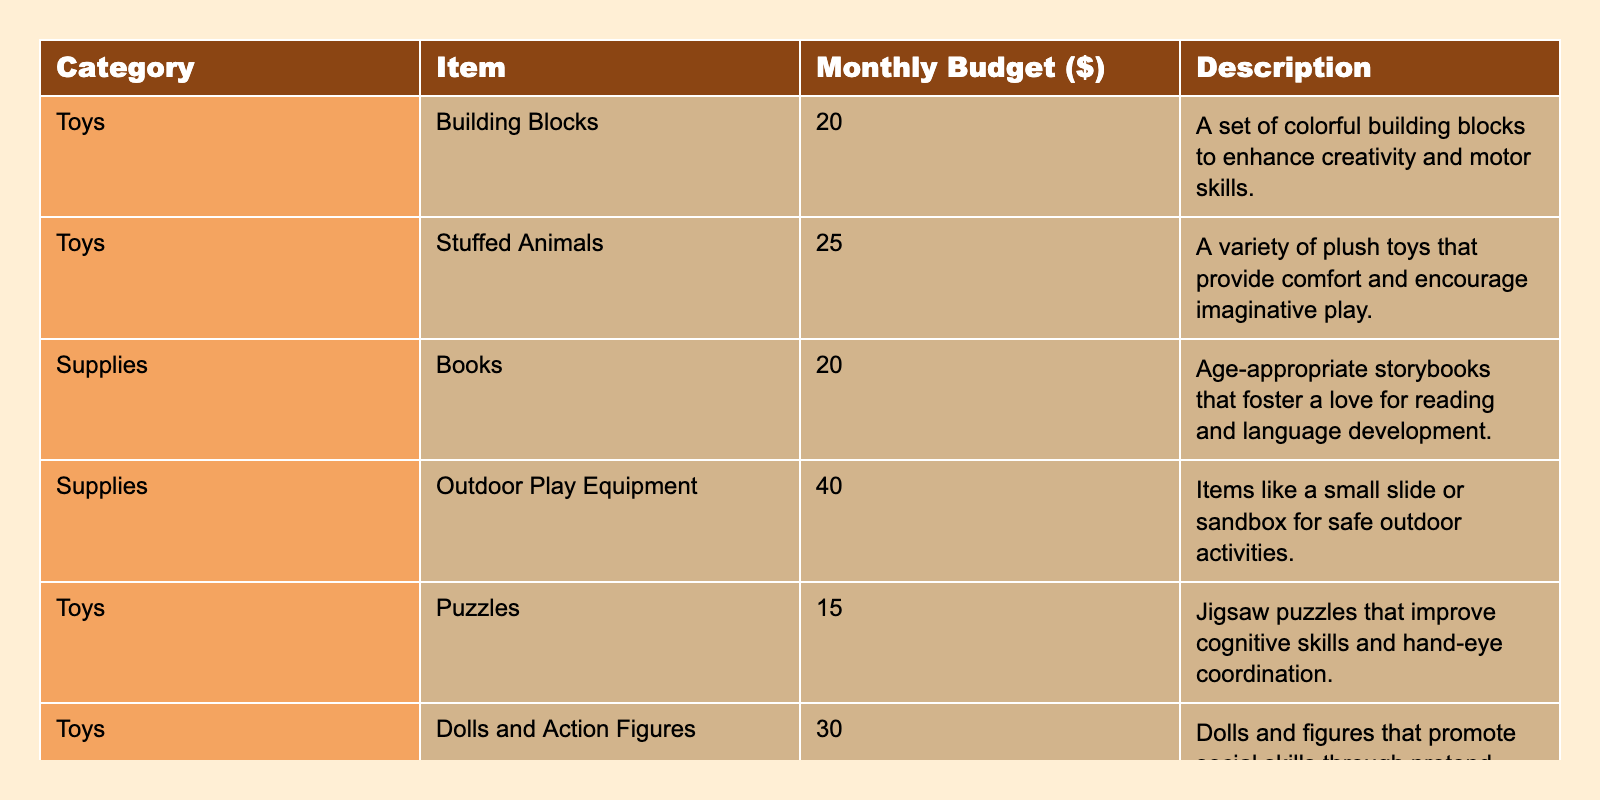What is the total monthly budget allocated for books? The table lists books under the supplies category with a budget of $20. Therefore, the total monthly allocation for books is simply this amount.
Answer: 20 How much more is allocated for outdoor play equipment compared to puzzles? The budget for outdoor play equipment is $40, and the budget for puzzles is $15. To find the difference, subtract 15 from 40, which equals 25.
Answer: 25 What is the total budget for toys? The monthly budgets for toys are: Building Blocks ($20), Stuffed Animals ($25), Puzzles ($15), Dolls and Action Figures ($30), and Musical Instruments ($25). Adding these amounts gives a total of 20 + 25 + 15 + 30 + 25 = 115.
Answer: 115 Are there more toys or supplies in the budget? The table shows 5 items under toys (Building Blocks, Stuffed Animals, Puzzles, Dolls and Action Figures, Musical Instruments) and 2 items under supplies (Books, Outdoor Play Equipment). Since 5 is greater than 2, the answer is yes.
Answer: Yes What is the average budget for toys? The budgets for toys are: $20, $25, $15, $30, $25. To calculate the average, first sum these values (20 + 25 + 15 + 30 + 25 = 115) and divide by the number of items (5). So, 115 divided by 5 equals 23.
Answer: 23 If you combine the budgets for supplies, what is the total? The total monthly budgets for supplies are: Books ($20) and Outdoor Play Equipment ($40). Adding these amounts, we get 20 + 40 = 60.
Answer: 60 Which item has the highest budget allocation? Looking through the items, Outdoor Play Equipment has a budget of $40, which is higher than all other items in the table. Therefore, it has the highest allocation.
Answer: Outdoor Play Equipment What is the combined budget for stuffed animals and musical instruments? The budget for stuffed animals is $25 and for musical instruments is $25 as well. Combining these budgets, we calculate 25 + 25 = 50.
Answer: 50 Is the budget for dolls and action figures equal to the budget for building blocks? The budget for dolls and action figures is $30, while building blocks is $20. Since 30 does not equal 20, the answer is no.
Answer: No What percentage of the total monthly budget (for all items) is allocated to toys? First, we need to find the total budget: 20 (Building Blocks) + 25 (Stuffed Animals) + 20 (Books) + 40 (Outdoor Play Equipment) + 15 (Puzzles) + 30 (Dolls) + 25 (Musical Instruments) = 175. The total for toys: 20 + 25 + 15 + 30 + 25 = 115. Now, calculate the percentage: (115/175) * 100 ≈ 65.71%.
Answer: 65.71% 